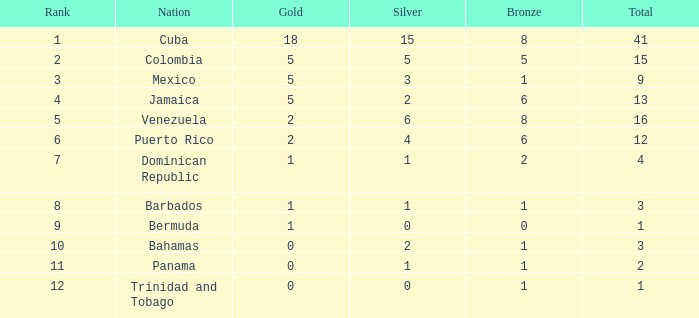Which Silver has a Gold of 2, and a Nation of puerto rico, and a Total smaller than 12? None. 